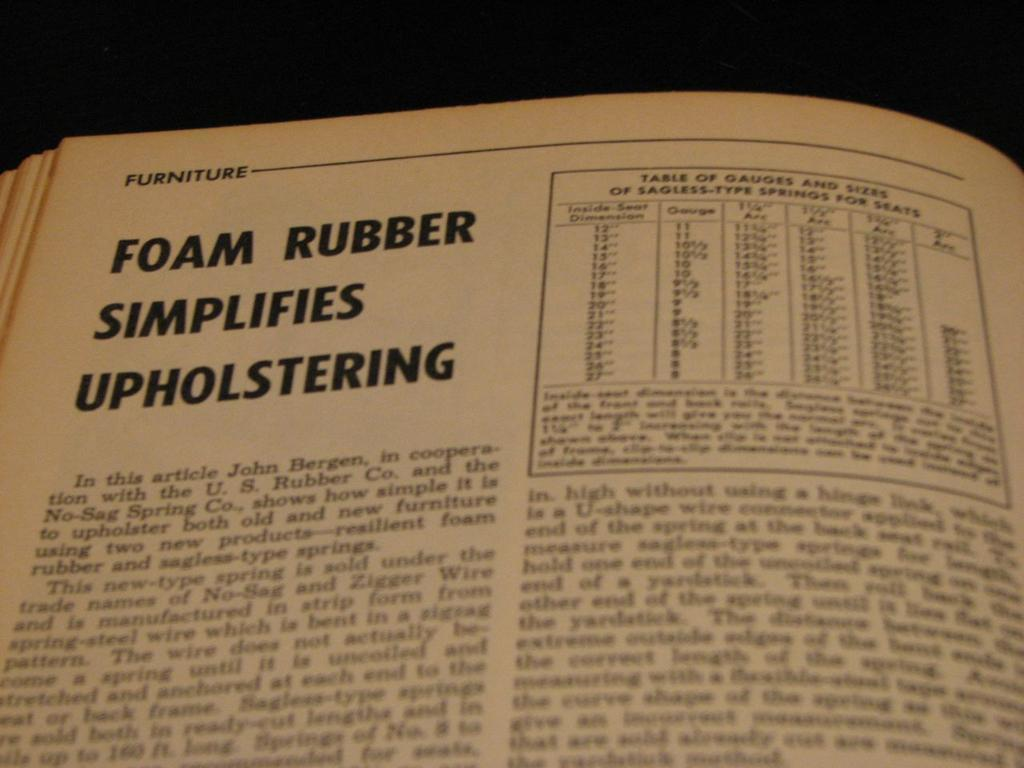<image>
Present a compact description of the photo's key features. A page from a book has a title about upholstering. 